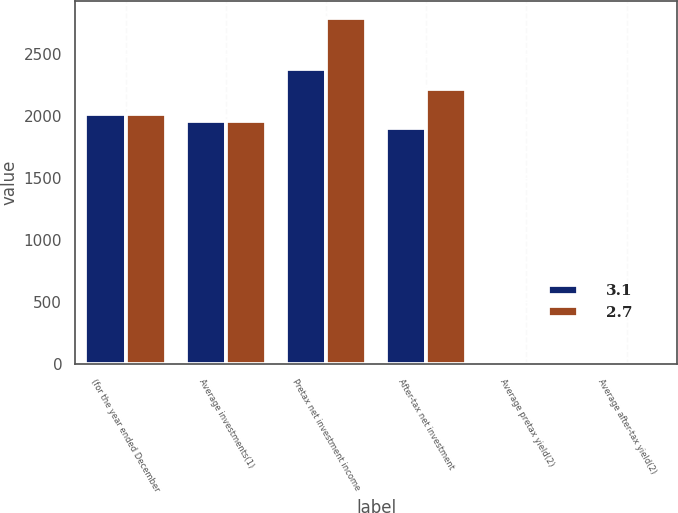<chart> <loc_0><loc_0><loc_500><loc_500><stacked_bar_chart><ecel><fcel>(for the year ended December<fcel>Average investments(1)<fcel>Pretax net investment income<fcel>After-tax net investment<fcel>Average pretax yield(2)<fcel>Average after-tax yield(2)<nl><fcel>3.1<fcel>2015<fcel>1959.5<fcel>2379<fcel>1905<fcel>3.4<fcel>2.7<nl><fcel>2.7<fcel>2014<fcel>1959.5<fcel>2787<fcel>2216<fcel>3.9<fcel>3.1<nl></chart> 